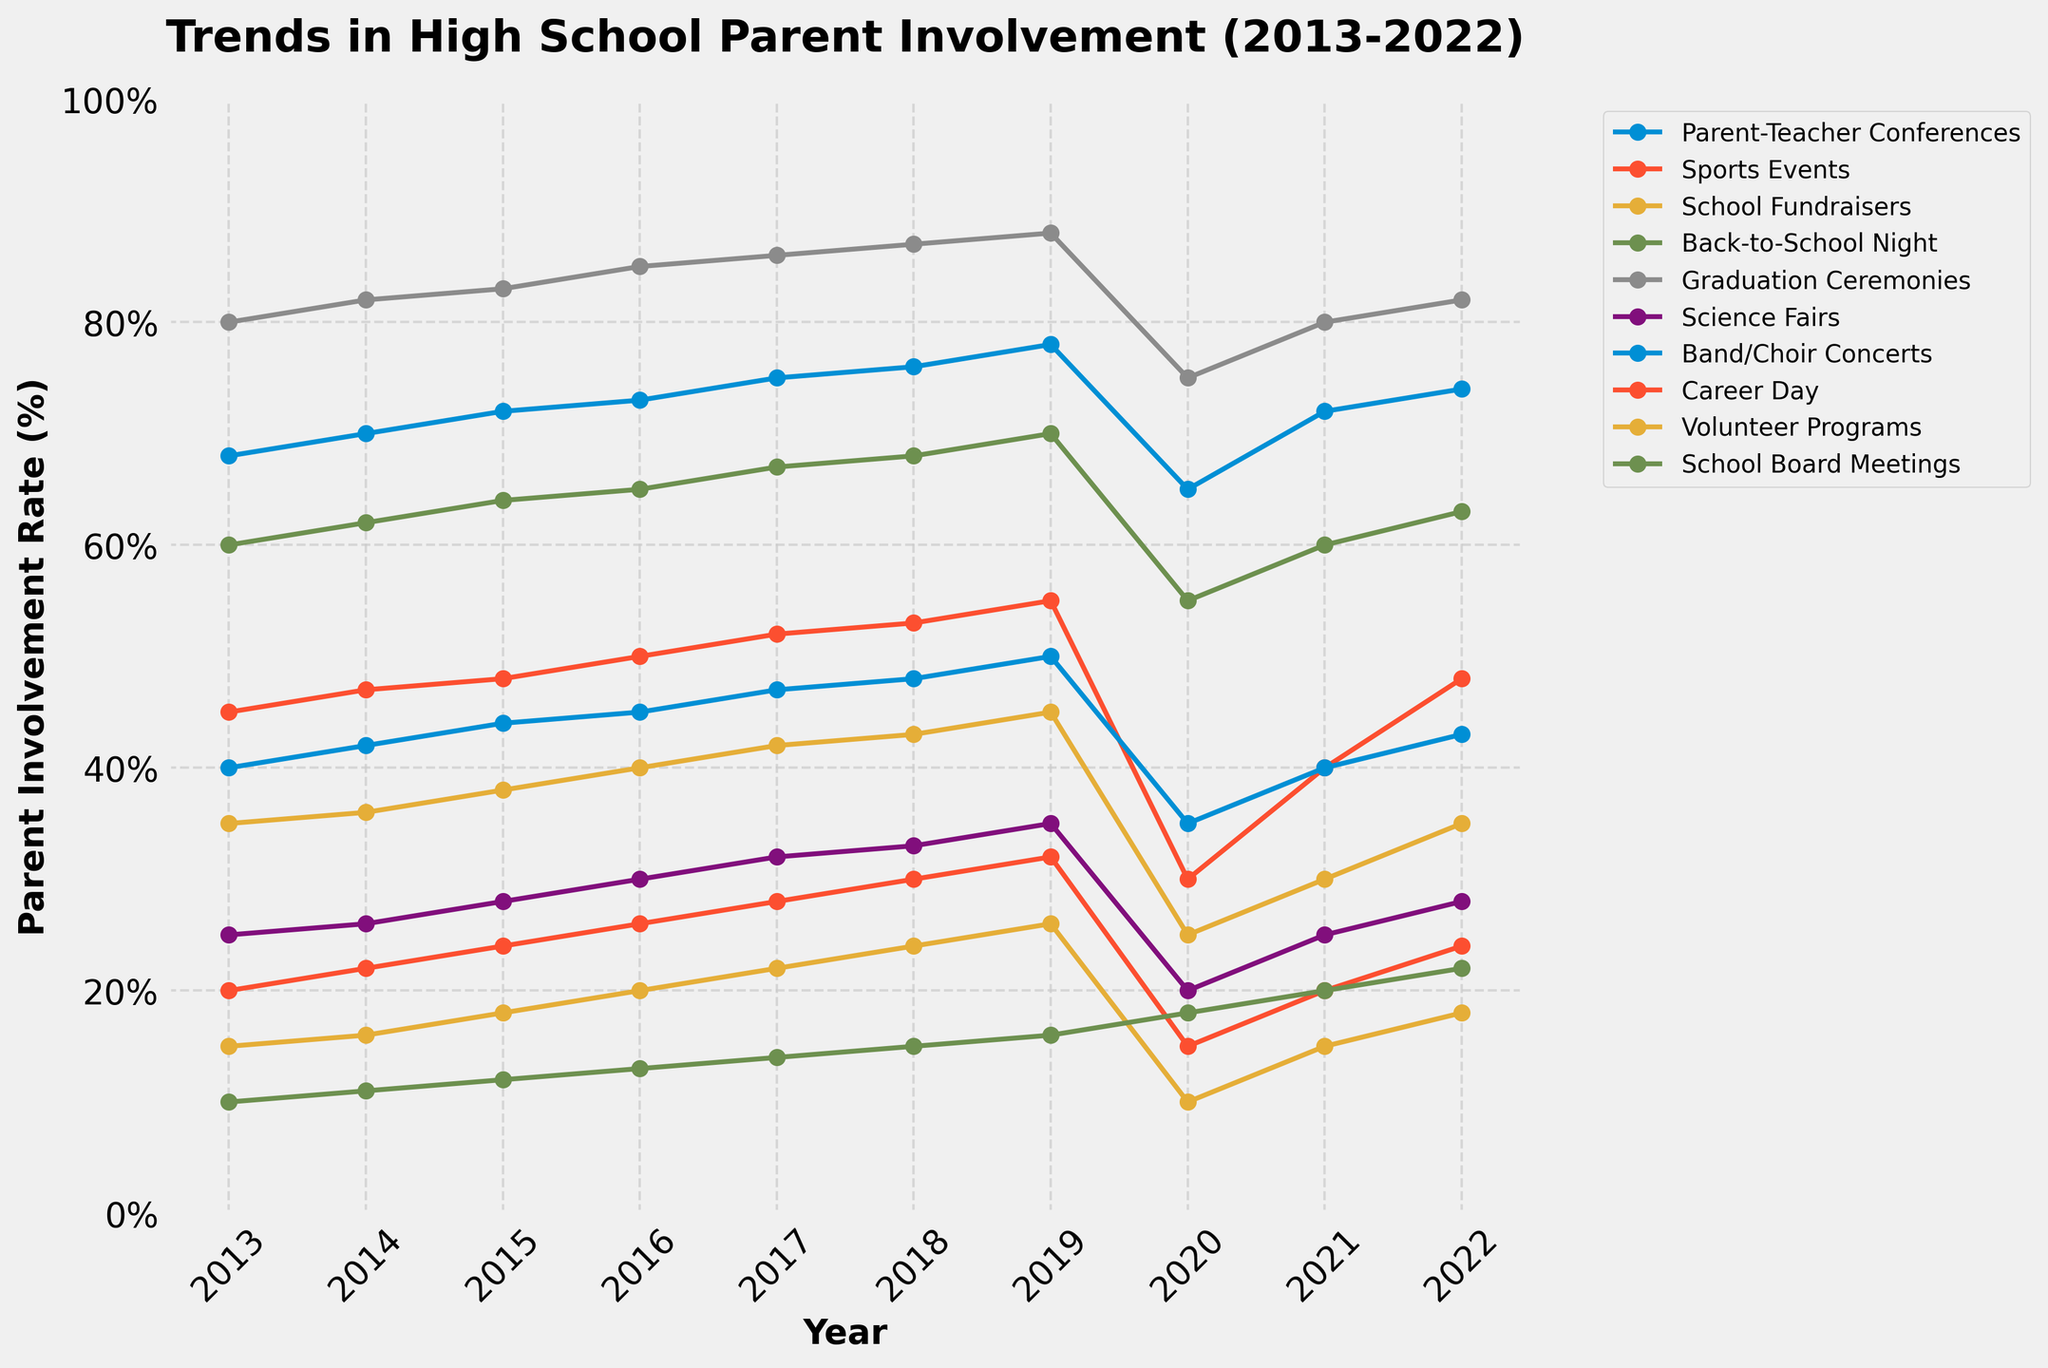What is the overall trend in parent involvement in Parent-Teacher Conferences from 2013 to 2022? Parent involvement in Parent-Teacher Conferences generally increased from 68% in 2013 to 78% in 2019, with a notable drop in 2020 to 65%, and then partially recovered to 74% in 2022.
Answer: Increased overall with a dip in 2020 Which event saw the largest drop in parent involvement in 2020? The chart indicates that volunteer programs had the steepest drop in parent involvement from 26% in 2019 to 10% in 2020.
Answer: Volunteer Programs How did parent involvement in Sports Events compare to Career Day in 2020? In 2020, parent involvement in Sports Events was significantly higher at 30%, compared to Career Day, which had a parent involvement rate of just 15%.
Answer: Sports Events had higher involvement What was the average parent involvement rate in Band/Choir Concerts from 2019 to 2022? To find the average, sum the parent involvement rates from 2019 to 2022 (50, 35, 40, 43) and divide by the number of years: (50 + 35 + 40 + 43) / 4 = 168 / 4 = 42%.
Answer: 42% Which event had the highest parent involvement rate in 2022, and what was the rate? The chart shows that Graduation Ceremonies had the highest parent involvement rate in 2022 at 82%.
Answer: Graduation Ceremonies at 82% How did the parent involvement rate in Science Fairs change from 2015 to 2017? The involvement rate in Science Fairs increased from 28% in 2015 to 30% in 2016, and further to 32% in 2017.
Answer: Increased by 4% What was the difference in parent involvement rates between the highest and lowest events in 2019? In 2019, Graduation Ceremonies had the highest involvement rate at 88%, and Volunteer Programs had the lowest at 26%. The difference is 88% - 26% = 62%.
Answer: 62% Which event saw the most considerable increase in parent involvement from 2013 to 2019? Parent-Teacher Conferences increased from 68% in 2013 to 78% in 2019, which is a 10 percentage points increase.
Answer: Parent-Teacher Conferences How did parent involvement in School Fundraisers change during the pandemic years (2020-2021)? Parent involvement in School Fundraisers dropped from 45% in 2019 to 25% in 2020 and then slightly increased to 30% in 2021.
Answer: Dropped initially, then slightly increased What is the overall trend in parent involvement for School Board Meetings from 2013 to 2022? The parent involvement rate in School Board Meetings gradually increased from 10% in 2013 to 16% in 2019 and then spiked to 22% by 2022.
Answer: Gradually increased 